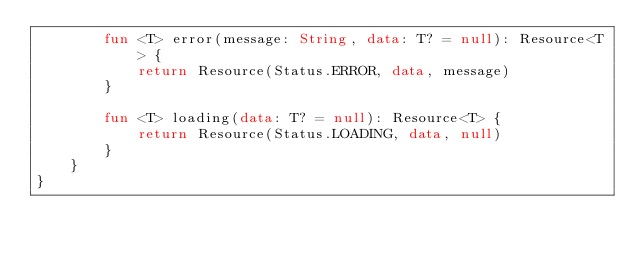Convert code to text. <code><loc_0><loc_0><loc_500><loc_500><_Kotlin_>        fun <T> error(message: String, data: T? = null): Resource<T> {
            return Resource(Status.ERROR, data, message)
        }

        fun <T> loading(data: T? = null): Resource<T> {
            return Resource(Status.LOADING, data, null)
        }
    }
}</code> 